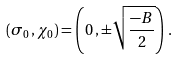<formula> <loc_0><loc_0><loc_500><loc_500>( \sigma _ { 0 } \, , \chi _ { 0 } ) = \left ( 0 \, , \pm \sqrt { \frac { - B } { 2 } } \right ) \, .</formula> 